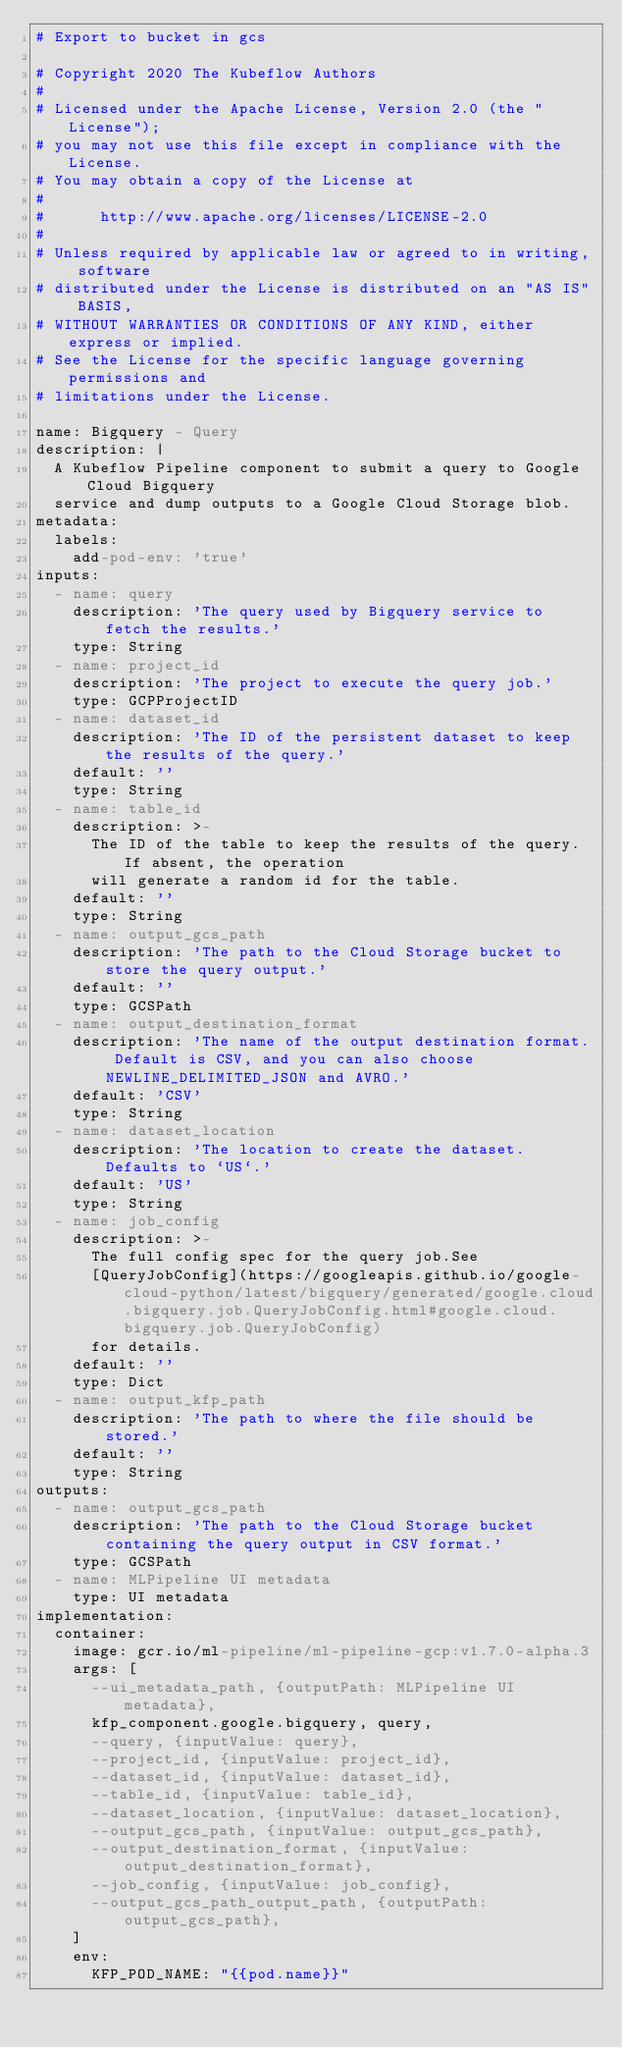Convert code to text. <code><loc_0><loc_0><loc_500><loc_500><_YAML_># Export to bucket in gcs

# Copyright 2020 The Kubeflow Authors
#
# Licensed under the Apache License, Version 2.0 (the "License");
# you may not use this file except in compliance with the License.
# You may obtain a copy of the License at
#
#      http://www.apache.org/licenses/LICENSE-2.0
#
# Unless required by applicable law or agreed to in writing, software
# distributed under the License is distributed on an "AS IS" BASIS,
# WITHOUT WARRANTIES OR CONDITIONS OF ANY KIND, either express or implied.
# See the License for the specific language governing permissions and
# limitations under the License.

name: Bigquery - Query
description: |
  A Kubeflow Pipeline component to submit a query to Google Cloud Bigquery 
  service and dump outputs to a Google Cloud Storage blob.
metadata:
  labels:
    add-pod-env: 'true'
inputs:
  - name: query
    description: 'The query used by Bigquery service to fetch the results.'
    type: String
  - name: project_id
    description: 'The project to execute the query job.'
    type: GCPProjectID
  - name: dataset_id
    description: 'The ID of the persistent dataset to keep the results of the query.'
    default: ''
    type: String
  - name: table_id
    description: >-
      The ID of the table to keep the results of the query. If absent, the operation
      will generate a random id for the table.
    default: '' 
    type: String
  - name: output_gcs_path
    description: 'The path to the Cloud Storage bucket to store the query output.'
    default: ''
    type: GCSPath
  - name: output_destination_format
    description: 'The name of the output destination format. Default is CSV, and you can also choose NEWLINE_DELIMITED_JSON and AVRO.'
    default: 'CSV'
    type: String
  - name: dataset_location
    description: 'The location to create the dataset. Defaults to `US`.'
    default: 'US'
    type: String
  - name: job_config
    description: >-
      The full config spec for the query job.See 
      [QueryJobConfig](https://googleapis.github.io/google-cloud-python/latest/bigquery/generated/google.cloud.bigquery.job.QueryJobConfig.html#google.cloud.bigquery.job.QueryJobConfig) 
      for details.
    default: ''
    type: Dict
  - name: output_kfp_path
    description: 'The path to where the file should be stored.'
    default: ''
    type: String
outputs:
  - name: output_gcs_path
    description: 'The path to the Cloud Storage bucket containing the query output in CSV format.'
    type: GCSPath
  - name: MLPipeline UI metadata
    type: UI metadata
implementation:
  container:
    image: gcr.io/ml-pipeline/ml-pipeline-gcp:v1.7.0-alpha.3
    args: [
      --ui_metadata_path, {outputPath: MLPipeline UI metadata},
      kfp_component.google.bigquery, query,
      --query, {inputValue: query},
      --project_id, {inputValue: project_id},
      --dataset_id, {inputValue: dataset_id},
      --table_id, {inputValue: table_id},
      --dataset_location, {inputValue: dataset_location},
      --output_gcs_path, {inputValue: output_gcs_path},
      --output_destination_format, {inputValue: output_destination_format},
      --job_config, {inputValue: job_config},
      --output_gcs_path_output_path, {outputPath: output_gcs_path},
    ]
    env:
      KFP_POD_NAME: "{{pod.name}}"
</code> 